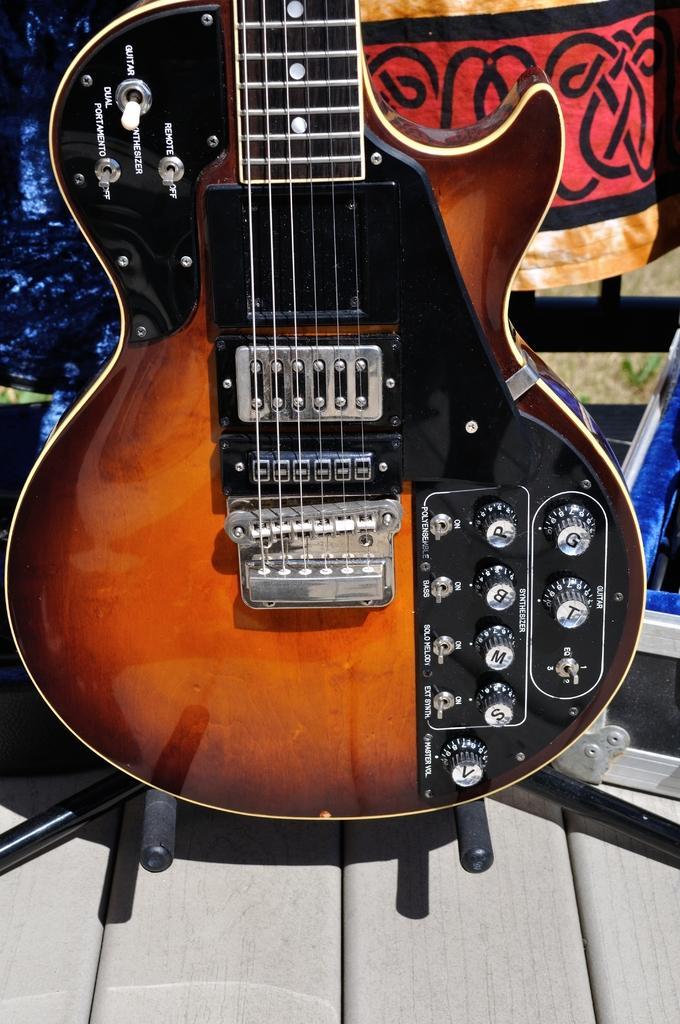In one or two sentences, can you explain what this image depicts? In the image in the center we can see guitar on the table. And coming to the background we can see some signboard. 